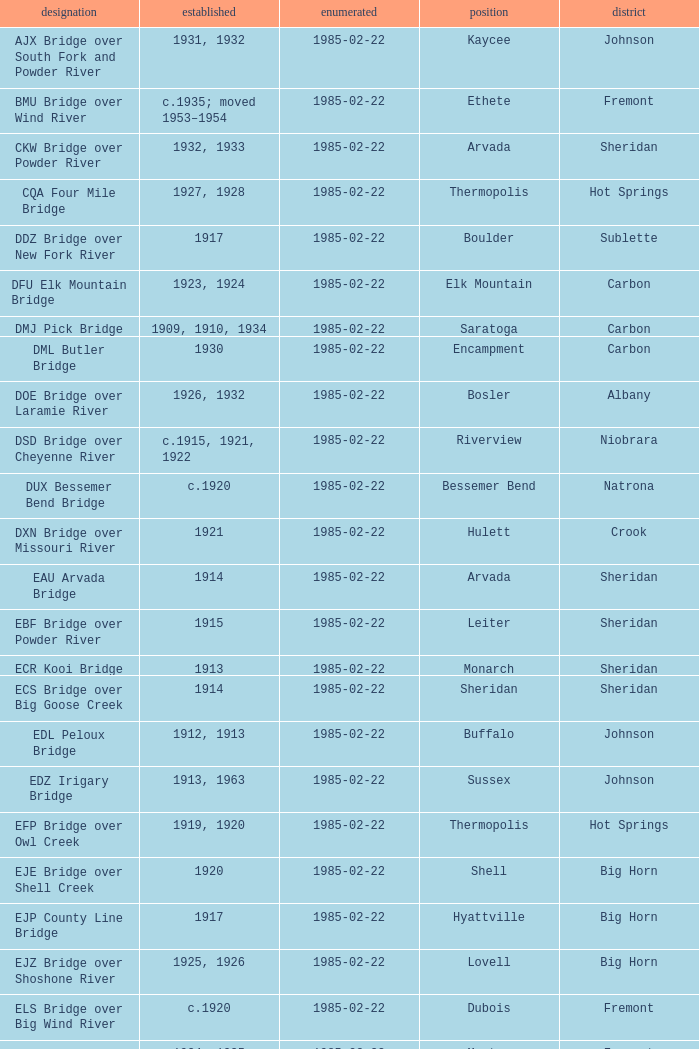Write the full table. {'header': ['designation', 'established', 'enumerated', 'position', 'district'], 'rows': [['AJX Bridge over South Fork and Powder River', '1931, 1932', '1985-02-22', 'Kaycee', 'Johnson'], ['BMU Bridge over Wind River', 'c.1935; moved 1953–1954', '1985-02-22', 'Ethete', 'Fremont'], ['CKW Bridge over Powder River', '1932, 1933', '1985-02-22', 'Arvada', 'Sheridan'], ['CQA Four Mile Bridge', '1927, 1928', '1985-02-22', 'Thermopolis', 'Hot Springs'], ['DDZ Bridge over New Fork River', '1917', '1985-02-22', 'Boulder', 'Sublette'], ['DFU Elk Mountain Bridge', '1923, 1924', '1985-02-22', 'Elk Mountain', 'Carbon'], ['DMJ Pick Bridge', '1909, 1910, 1934', '1985-02-22', 'Saratoga', 'Carbon'], ['DML Butler Bridge', '1930', '1985-02-22', 'Encampment', 'Carbon'], ['DOE Bridge over Laramie River', '1926, 1932', '1985-02-22', 'Bosler', 'Albany'], ['DSD Bridge over Cheyenne River', 'c.1915, 1921, 1922', '1985-02-22', 'Riverview', 'Niobrara'], ['DUX Bessemer Bend Bridge', 'c.1920', '1985-02-22', 'Bessemer Bend', 'Natrona'], ['DXN Bridge over Missouri River', '1921', '1985-02-22', 'Hulett', 'Crook'], ['EAU Arvada Bridge', '1914', '1985-02-22', 'Arvada', 'Sheridan'], ['EBF Bridge over Powder River', '1915', '1985-02-22', 'Leiter', 'Sheridan'], ['ECR Kooi Bridge', '1913', '1985-02-22', 'Monarch', 'Sheridan'], ['ECS Bridge over Big Goose Creek', '1914', '1985-02-22', 'Sheridan', 'Sheridan'], ['EDL Peloux Bridge', '1912, 1913', '1985-02-22', 'Buffalo', 'Johnson'], ['EDZ Irigary Bridge', '1913, 1963', '1985-02-22', 'Sussex', 'Johnson'], ['EFP Bridge over Owl Creek', '1919, 1920', '1985-02-22', 'Thermopolis', 'Hot Springs'], ['EJE Bridge over Shell Creek', '1920', '1985-02-22', 'Shell', 'Big Horn'], ['EJP County Line Bridge', '1917', '1985-02-22', 'Hyattville', 'Big Horn'], ['EJZ Bridge over Shoshone River', '1925, 1926', '1985-02-22', 'Lovell', 'Big Horn'], ['ELS Bridge over Big Wind River', 'c.1920', '1985-02-22', 'Dubois', 'Fremont'], ['ELY Wind River Diversion Dam Bridge', '1924, 1925', '1985-02-22', 'Morton', 'Fremont'], ['ENP Bridge over Green River', 'c.1905', '1985-02-22', 'Daniel', 'Sublette'], ["ERT Bridge over Black's Fork", 'c.1920', '1985-02-22', 'Fort Bridger', 'Uinta'], ['ETD Bridge over Green River', '1913', '1985-02-22', 'Fontenelle', 'Sweetwater'], ['ETR Big Island Bridge', '1909, 1910', '1985-02-22', 'Green River', 'Sweetwater'], ['EWZ Bridge over East Channel of Laramie River', '1913, 1914', '1985-02-22', 'Wheatland', 'Platte'], ['Hayden Arch Bridge', '1924, 1925', '1985-02-22', 'Cody', 'Park'], ['Rairden Bridge', '1916', '1985-02-22', 'Manderson', 'Big Horn']]} In which county can the bridge in boulder be found? Sublette. 